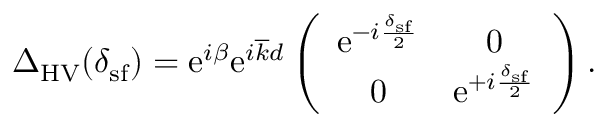<formula> <loc_0><loc_0><loc_500><loc_500>\begin{array} { r } { \Delta _ { H V } ( \delta _ { s f } ) = e ^ { i \beta } e ^ { i \overline { k } d } \left ( \begin{array} { c c } { e ^ { - i \frac { \delta _ { s f } } { 2 } } } & { 0 } \\ { 0 } & { e ^ { + i \frac { \delta _ { s f } } { 2 } } } \end{array} \right ) . } \end{array}</formula> 